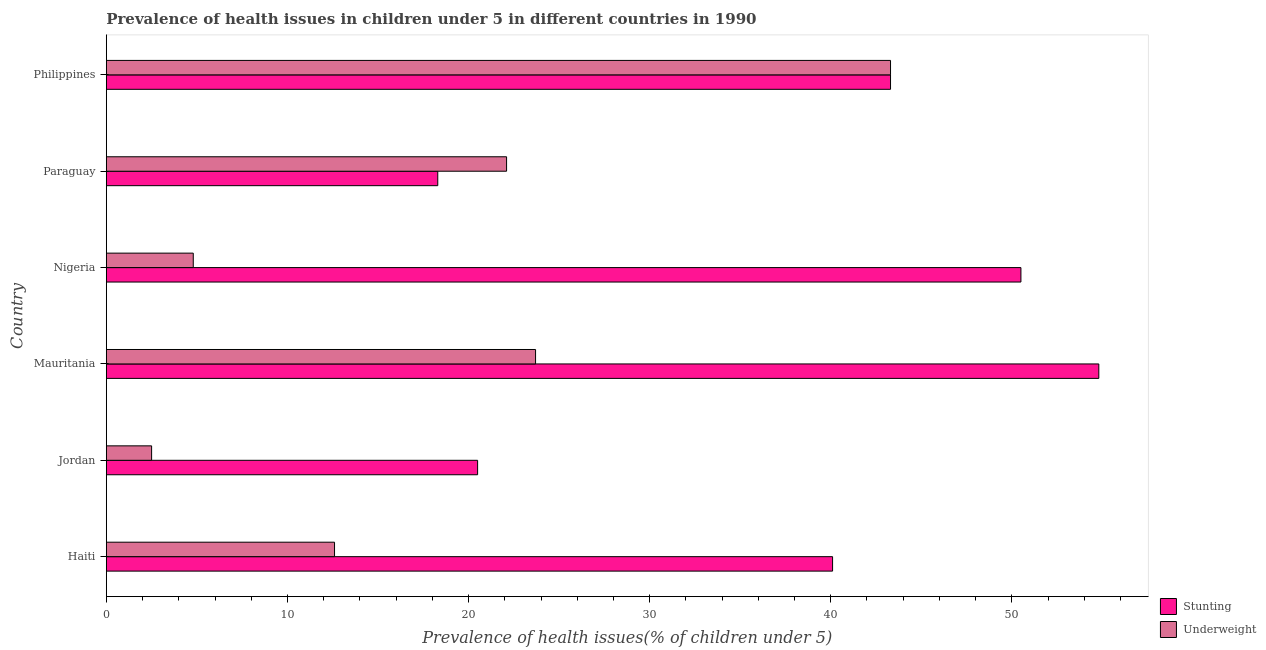How many different coloured bars are there?
Keep it short and to the point. 2. Are the number of bars on each tick of the Y-axis equal?
Offer a very short reply. Yes. What is the label of the 4th group of bars from the top?
Ensure brevity in your answer.  Mauritania. In how many cases, is the number of bars for a given country not equal to the number of legend labels?
Your answer should be compact. 0. What is the percentage of underweight children in Nigeria?
Keep it short and to the point. 4.8. Across all countries, what is the maximum percentage of underweight children?
Provide a succinct answer. 43.3. Across all countries, what is the minimum percentage of stunted children?
Provide a succinct answer. 18.3. In which country was the percentage of stunted children maximum?
Provide a short and direct response. Mauritania. In which country was the percentage of underweight children minimum?
Provide a short and direct response. Jordan. What is the total percentage of underweight children in the graph?
Ensure brevity in your answer.  109. What is the difference between the percentage of underweight children in Jordan and the percentage of stunted children in Mauritania?
Your answer should be very brief. -52.3. What is the average percentage of underweight children per country?
Make the answer very short. 18.17. What is the difference between the percentage of stunted children and percentage of underweight children in Jordan?
Offer a terse response. 18. In how many countries, is the percentage of underweight children greater than 36 %?
Keep it short and to the point. 1. What is the ratio of the percentage of underweight children in Jordan to that in Nigeria?
Your response must be concise. 0.52. Is the difference between the percentage of underweight children in Mauritania and Philippines greater than the difference between the percentage of stunted children in Mauritania and Philippines?
Keep it short and to the point. No. What is the difference between the highest and the lowest percentage of underweight children?
Provide a succinct answer. 40.8. What does the 1st bar from the top in Mauritania represents?
Keep it short and to the point. Underweight. What does the 1st bar from the bottom in Mauritania represents?
Your answer should be very brief. Stunting. How many bars are there?
Make the answer very short. 12. Does the graph contain any zero values?
Your answer should be very brief. No. How many legend labels are there?
Make the answer very short. 2. What is the title of the graph?
Your answer should be compact. Prevalence of health issues in children under 5 in different countries in 1990. Does "Subsidies" appear as one of the legend labels in the graph?
Your response must be concise. No. What is the label or title of the X-axis?
Your answer should be very brief. Prevalence of health issues(% of children under 5). What is the Prevalence of health issues(% of children under 5) of Stunting in Haiti?
Your answer should be compact. 40.1. What is the Prevalence of health issues(% of children under 5) of Underweight in Haiti?
Your answer should be very brief. 12.6. What is the Prevalence of health issues(% of children under 5) of Stunting in Jordan?
Provide a short and direct response. 20.5. What is the Prevalence of health issues(% of children under 5) of Underweight in Jordan?
Give a very brief answer. 2.5. What is the Prevalence of health issues(% of children under 5) in Stunting in Mauritania?
Offer a very short reply. 54.8. What is the Prevalence of health issues(% of children under 5) in Underweight in Mauritania?
Your answer should be compact. 23.7. What is the Prevalence of health issues(% of children under 5) in Stunting in Nigeria?
Your answer should be very brief. 50.5. What is the Prevalence of health issues(% of children under 5) of Underweight in Nigeria?
Your response must be concise. 4.8. What is the Prevalence of health issues(% of children under 5) of Stunting in Paraguay?
Offer a terse response. 18.3. What is the Prevalence of health issues(% of children under 5) in Underweight in Paraguay?
Provide a short and direct response. 22.1. What is the Prevalence of health issues(% of children under 5) in Stunting in Philippines?
Your response must be concise. 43.3. What is the Prevalence of health issues(% of children under 5) in Underweight in Philippines?
Your answer should be compact. 43.3. Across all countries, what is the maximum Prevalence of health issues(% of children under 5) of Stunting?
Your answer should be very brief. 54.8. Across all countries, what is the maximum Prevalence of health issues(% of children under 5) of Underweight?
Provide a succinct answer. 43.3. Across all countries, what is the minimum Prevalence of health issues(% of children under 5) in Stunting?
Keep it short and to the point. 18.3. What is the total Prevalence of health issues(% of children under 5) in Stunting in the graph?
Your response must be concise. 227.5. What is the total Prevalence of health issues(% of children under 5) in Underweight in the graph?
Ensure brevity in your answer.  109. What is the difference between the Prevalence of health issues(% of children under 5) of Stunting in Haiti and that in Jordan?
Your response must be concise. 19.6. What is the difference between the Prevalence of health issues(% of children under 5) of Stunting in Haiti and that in Mauritania?
Give a very brief answer. -14.7. What is the difference between the Prevalence of health issues(% of children under 5) in Stunting in Haiti and that in Paraguay?
Your answer should be very brief. 21.8. What is the difference between the Prevalence of health issues(% of children under 5) in Underweight in Haiti and that in Paraguay?
Offer a very short reply. -9.5. What is the difference between the Prevalence of health issues(% of children under 5) in Underweight in Haiti and that in Philippines?
Your response must be concise. -30.7. What is the difference between the Prevalence of health issues(% of children under 5) of Stunting in Jordan and that in Mauritania?
Make the answer very short. -34.3. What is the difference between the Prevalence of health issues(% of children under 5) in Underweight in Jordan and that in Mauritania?
Provide a short and direct response. -21.2. What is the difference between the Prevalence of health issues(% of children under 5) of Underweight in Jordan and that in Paraguay?
Give a very brief answer. -19.6. What is the difference between the Prevalence of health issues(% of children under 5) of Stunting in Jordan and that in Philippines?
Keep it short and to the point. -22.8. What is the difference between the Prevalence of health issues(% of children under 5) in Underweight in Jordan and that in Philippines?
Give a very brief answer. -40.8. What is the difference between the Prevalence of health issues(% of children under 5) in Stunting in Mauritania and that in Paraguay?
Your response must be concise. 36.5. What is the difference between the Prevalence of health issues(% of children under 5) in Underweight in Mauritania and that in Philippines?
Your answer should be compact. -19.6. What is the difference between the Prevalence of health issues(% of children under 5) in Stunting in Nigeria and that in Paraguay?
Offer a very short reply. 32.2. What is the difference between the Prevalence of health issues(% of children under 5) in Underweight in Nigeria and that in Paraguay?
Your response must be concise. -17.3. What is the difference between the Prevalence of health issues(% of children under 5) in Underweight in Nigeria and that in Philippines?
Make the answer very short. -38.5. What is the difference between the Prevalence of health issues(% of children under 5) of Underweight in Paraguay and that in Philippines?
Your response must be concise. -21.2. What is the difference between the Prevalence of health issues(% of children under 5) in Stunting in Haiti and the Prevalence of health issues(% of children under 5) in Underweight in Jordan?
Provide a succinct answer. 37.6. What is the difference between the Prevalence of health issues(% of children under 5) in Stunting in Haiti and the Prevalence of health issues(% of children under 5) in Underweight in Nigeria?
Offer a terse response. 35.3. What is the difference between the Prevalence of health issues(% of children under 5) in Stunting in Jordan and the Prevalence of health issues(% of children under 5) in Underweight in Mauritania?
Your answer should be compact. -3.2. What is the difference between the Prevalence of health issues(% of children under 5) of Stunting in Jordan and the Prevalence of health issues(% of children under 5) of Underweight in Nigeria?
Provide a short and direct response. 15.7. What is the difference between the Prevalence of health issues(% of children under 5) of Stunting in Jordan and the Prevalence of health issues(% of children under 5) of Underweight in Philippines?
Keep it short and to the point. -22.8. What is the difference between the Prevalence of health issues(% of children under 5) in Stunting in Mauritania and the Prevalence of health issues(% of children under 5) in Underweight in Paraguay?
Provide a short and direct response. 32.7. What is the difference between the Prevalence of health issues(% of children under 5) of Stunting in Mauritania and the Prevalence of health issues(% of children under 5) of Underweight in Philippines?
Offer a very short reply. 11.5. What is the difference between the Prevalence of health issues(% of children under 5) in Stunting in Nigeria and the Prevalence of health issues(% of children under 5) in Underweight in Paraguay?
Offer a very short reply. 28.4. What is the average Prevalence of health issues(% of children under 5) in Stunting per country?
Give a very brief answer. 37.92. What is the average Prevalence of health issues(% of children under 5) of Underweight per country?
Give a very brief answer. 18.17. What is the difference between the Prevalence of health issues(% of children under 5) in Stunting and Prevalence of health issues(% of children under 5) in Underweight in Mauritania?
Offer a very short reply. 31.1. What is the difference between the Prevalence of health issues(% of children under 5) in Stunting and Prevalence of health issues(% of children under 5) in Underweight in Nigeria?
Ensure brevity in your answer.  45.7. What is the difference between the Prevalence of health issues(% of children under 5) in Stunting and Prevalence of health issues(% of children under 5) in Underweight in Philippines?
Provide a short and direct response. 0. What is the ratio of the Prevalence of health issues(% of children under 5) of Stunting in Haiti to that in Jordan?
Provide a short and direct response. 1.96. What is the ratio of the Prevalence of health issues(% of children under 5) in Underweight in Haiti to that in Jordan?
Provide a succinct answer. 5.04. What is the ratio of the Prevalence of health issues(% of children under 5) in Stunting in Haiti to that in Mauritania?
Make the answer very short. 0.73. What is the ratio of the Prevalence of health issues(% of children under 5) in Underweight in Haiti to that in Mauritania?
Make the answer very short. 0.53. What is the ratio of the Prevalence of health issues(% of children under 5) in Stunting in Haiti to that in Nigeria?
Your answer should be compact. 0.79. What is the ratio of the Prevalence of health issues(% of children under 5) of Underweight in Haiti to that in Nigeria?
Provide a short and direct response. 2.62. What is the ratio of the Prevalence of health issues(% of children under 5) of Stunting in Haiti to that in Paraguay?
Your answer should be very brief. 2.19. What is the ratio of the Prevalence of health issues(% of children under 5) of Underweight in Haiti to that in Paraguay?
Keep it short and to the point. 0.57. What is the ratio of the Prevalence of health issues(% of children under 5) of Stunting in Haiti to that in Philippines?
Your answer should be very brief. 0.93. What is the ratio of the Prevalence of health issues(% of children under 5) of Underweight in Haiti to that in Philippines?
Make the answer very short. 0.29. What is the ratio of the Prevalence of health issues(% of children under 5) in Stunting in Jordan to that in Mauritania?
Ensure brevity in your answer.  0.37. What is the ratio of the Prevalence of health issues(% of children under 5) of Underweight in Jordan to that in Mauritania?
Offer a terse response. 0.11. What is the ratio of the Prevalence of health issues(% of children under 5) in Stunting in Jordan to that in Nigeria?
Your answer should be very brief. 0.41. What is the ratio of the Prevalence of health issues(% of children under 5) in Underweight in Jordan to that in Nigeria?
Your response must be concise. 0.52. What is the ratio of the Prevalence of health issues(% of children under 5) in Stunting in Jordan to that in Paraguay?
Provide a succinct answer. 1.12. What is the ratio of the Prevalence of health issues(% of children under 5) of Underweight in Jordan to that in Paraguay?
Offer a terse response. 0.11. What is the ratio of the Prevalence of health issues(% of children under 5) in Stunting in Jordan to that in Philippines?
Make the answer very short. 0.47. What is the ratio of the Prevalence of health issues(% of children under 5) in Underweight in Jordan to that in Philippines?
Give a very brief answer. 0.06. What is the ratio of the Prevalence of health issues(% of children under 5) in Stunting in Mauritania to that in Nigeria?
Your response must be concise. 1.09. What is the ratio of the Prevalence of health issues(% of children under 5) of Underweight in Mauritania to that in Nigeria?
Offer a very short reply. 4.94. What is the ratio of the Prevalence of health issues(% of children under 5) in Stunting in Mauritania to that in Paraguay?
Provide a succinct answer. 2.99. What is the ratio of the Prevalence of health issues(% of children under 5) of Underweight in Mauritania to that in Paraguay?
Your answer should be very brief. 1.07. What is the ratio of the Prevalence of health issues(% of children under 5) in Stunting in Mauritania to that in Philippines?
Offer a very short reply. 1.27. What is the ratio of the Prevalence of health issues(% of children under 5) of Underweight in Mauritania to that in Philippines?
Keep it short and to the point. 0.55. What is the ratio of the Prevalence of health issues(% of children under 5) of Stunting in Nigeria to that in Paraguay?
Your response must be concise. 2.76. What is the ratio of the Prevalence of health issues(% of children under 5) of Underweight in Nigeria to that in Paraguay?
Make the answer very short. 0.22. What is the ratio of the Prevalence of health issues(% of children under 5) of Stunting in Nigeria to that in Philippines?
Give a very brief answer. 1.17. What is the ratio of the Prevalence of health issues(% of children under 5) of Underweight in Nigeria to that in Philippines?
Your answer should be very brief. 0.11. What is the ratio of the Prevalence of health issues(% of children under 5) of Stunting in Paraguay to that in Philippines?
Offer a terse response. 0.42. What is the ratio of the Prevalence of health issues(% of children under 5) in Underweight in Paraguay to that in Philippines?
Offer a terse response. 0.51. What is the difference between the highest and the second highest Prevalence of health issues(% of children under 5) of Underweight?
Give a very brief answer. 19.6. What is the difference between the highest and the lowest Prevalence of health issues(% of children under 5) of Stunting?
Your answer should be very brief. 36.5. What is the difference between the highest and the lowest Prevalence of health issues(% of children under 5) in Underweight?
Your answer should be very brief. 40.8. 